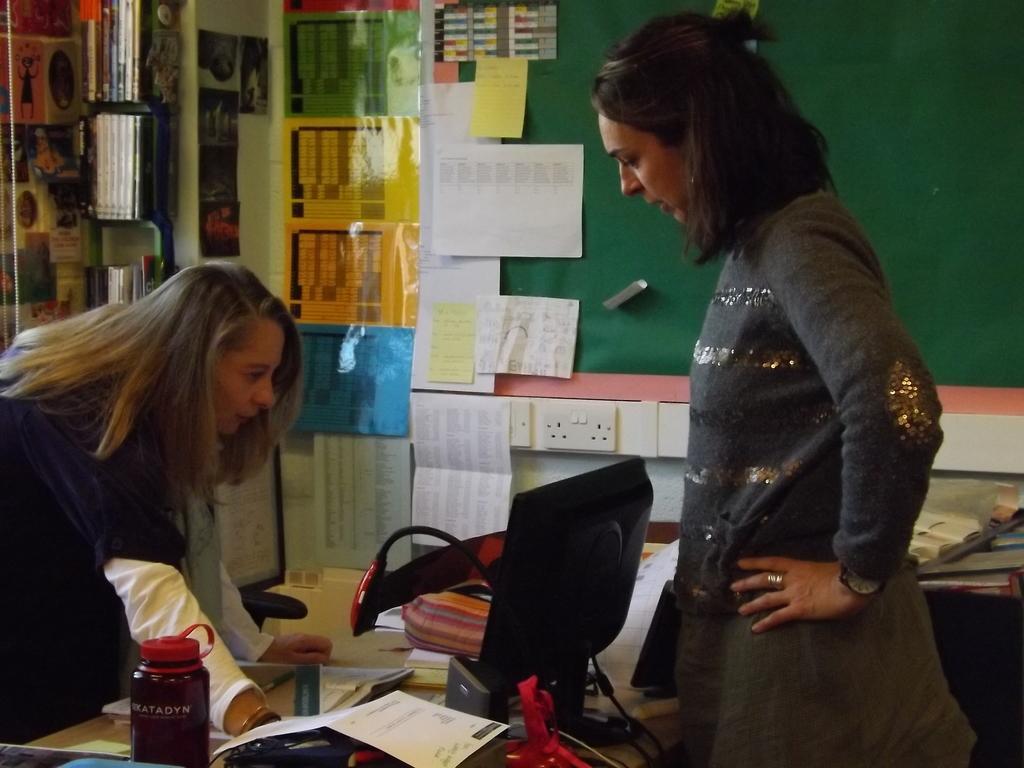Can you describe this image briefly? In this image, at the right side there is a woman standing and we can see a black color monitor, at the left side there is a girl looking at the monitor, in the background there is a green color board, there are some papers on the wall, we can see some white color switch boards. 